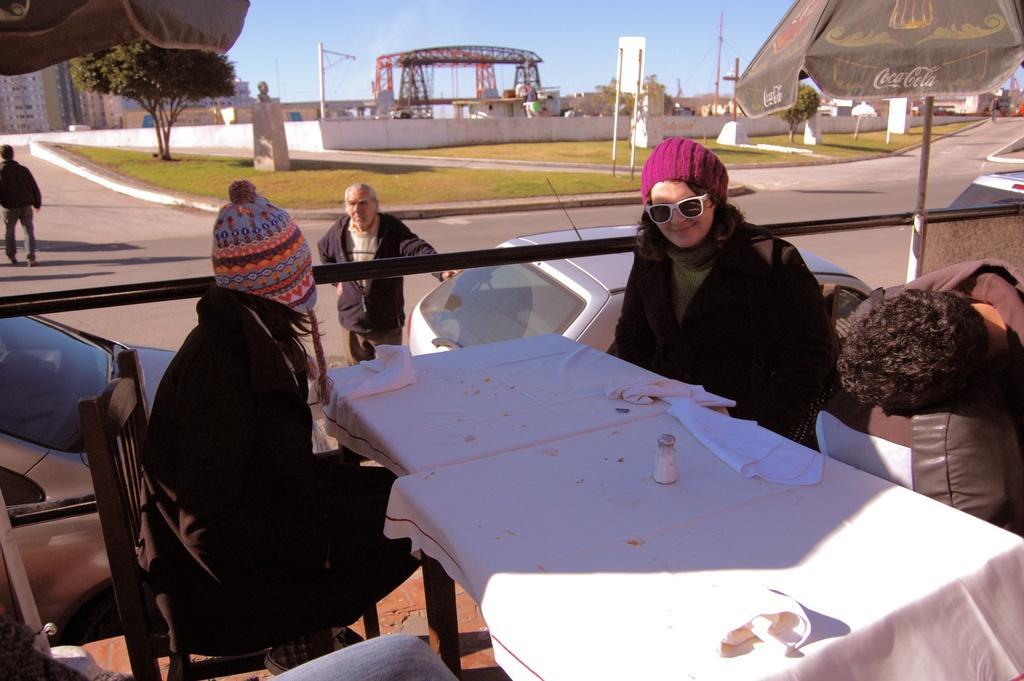How would you summarize this image in a sentence or two? In the image we can see there are people sitting on the chair, there is cloth and salt bottle kept on the table. There are cars parked on the road and there are people standing on the road. The ground is covered with grass and there are trees. There are buildings and there is a tent. The sky is clear. 